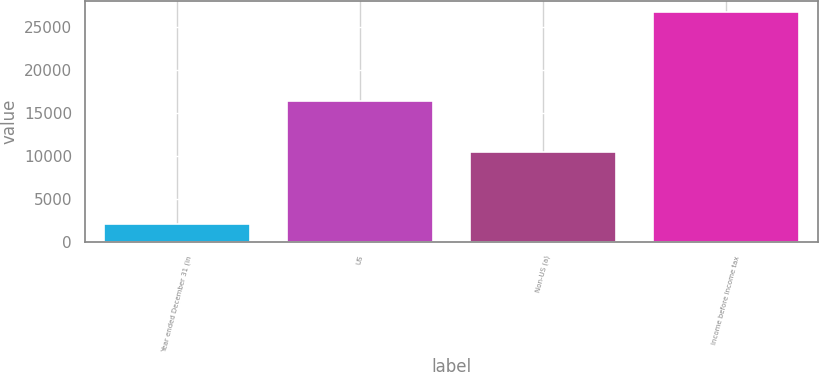Convert chart. <chart><loc_0><loc_0><loc_500><loc_500><bar_chart><fcel>Year ended December 31 (in<fcel>US<fcel>Non-US (a)<fcel>Income before income tax<nl><fcel>2011<fcel>16336<fcel>10413<fcel>26749<nl></chart> 